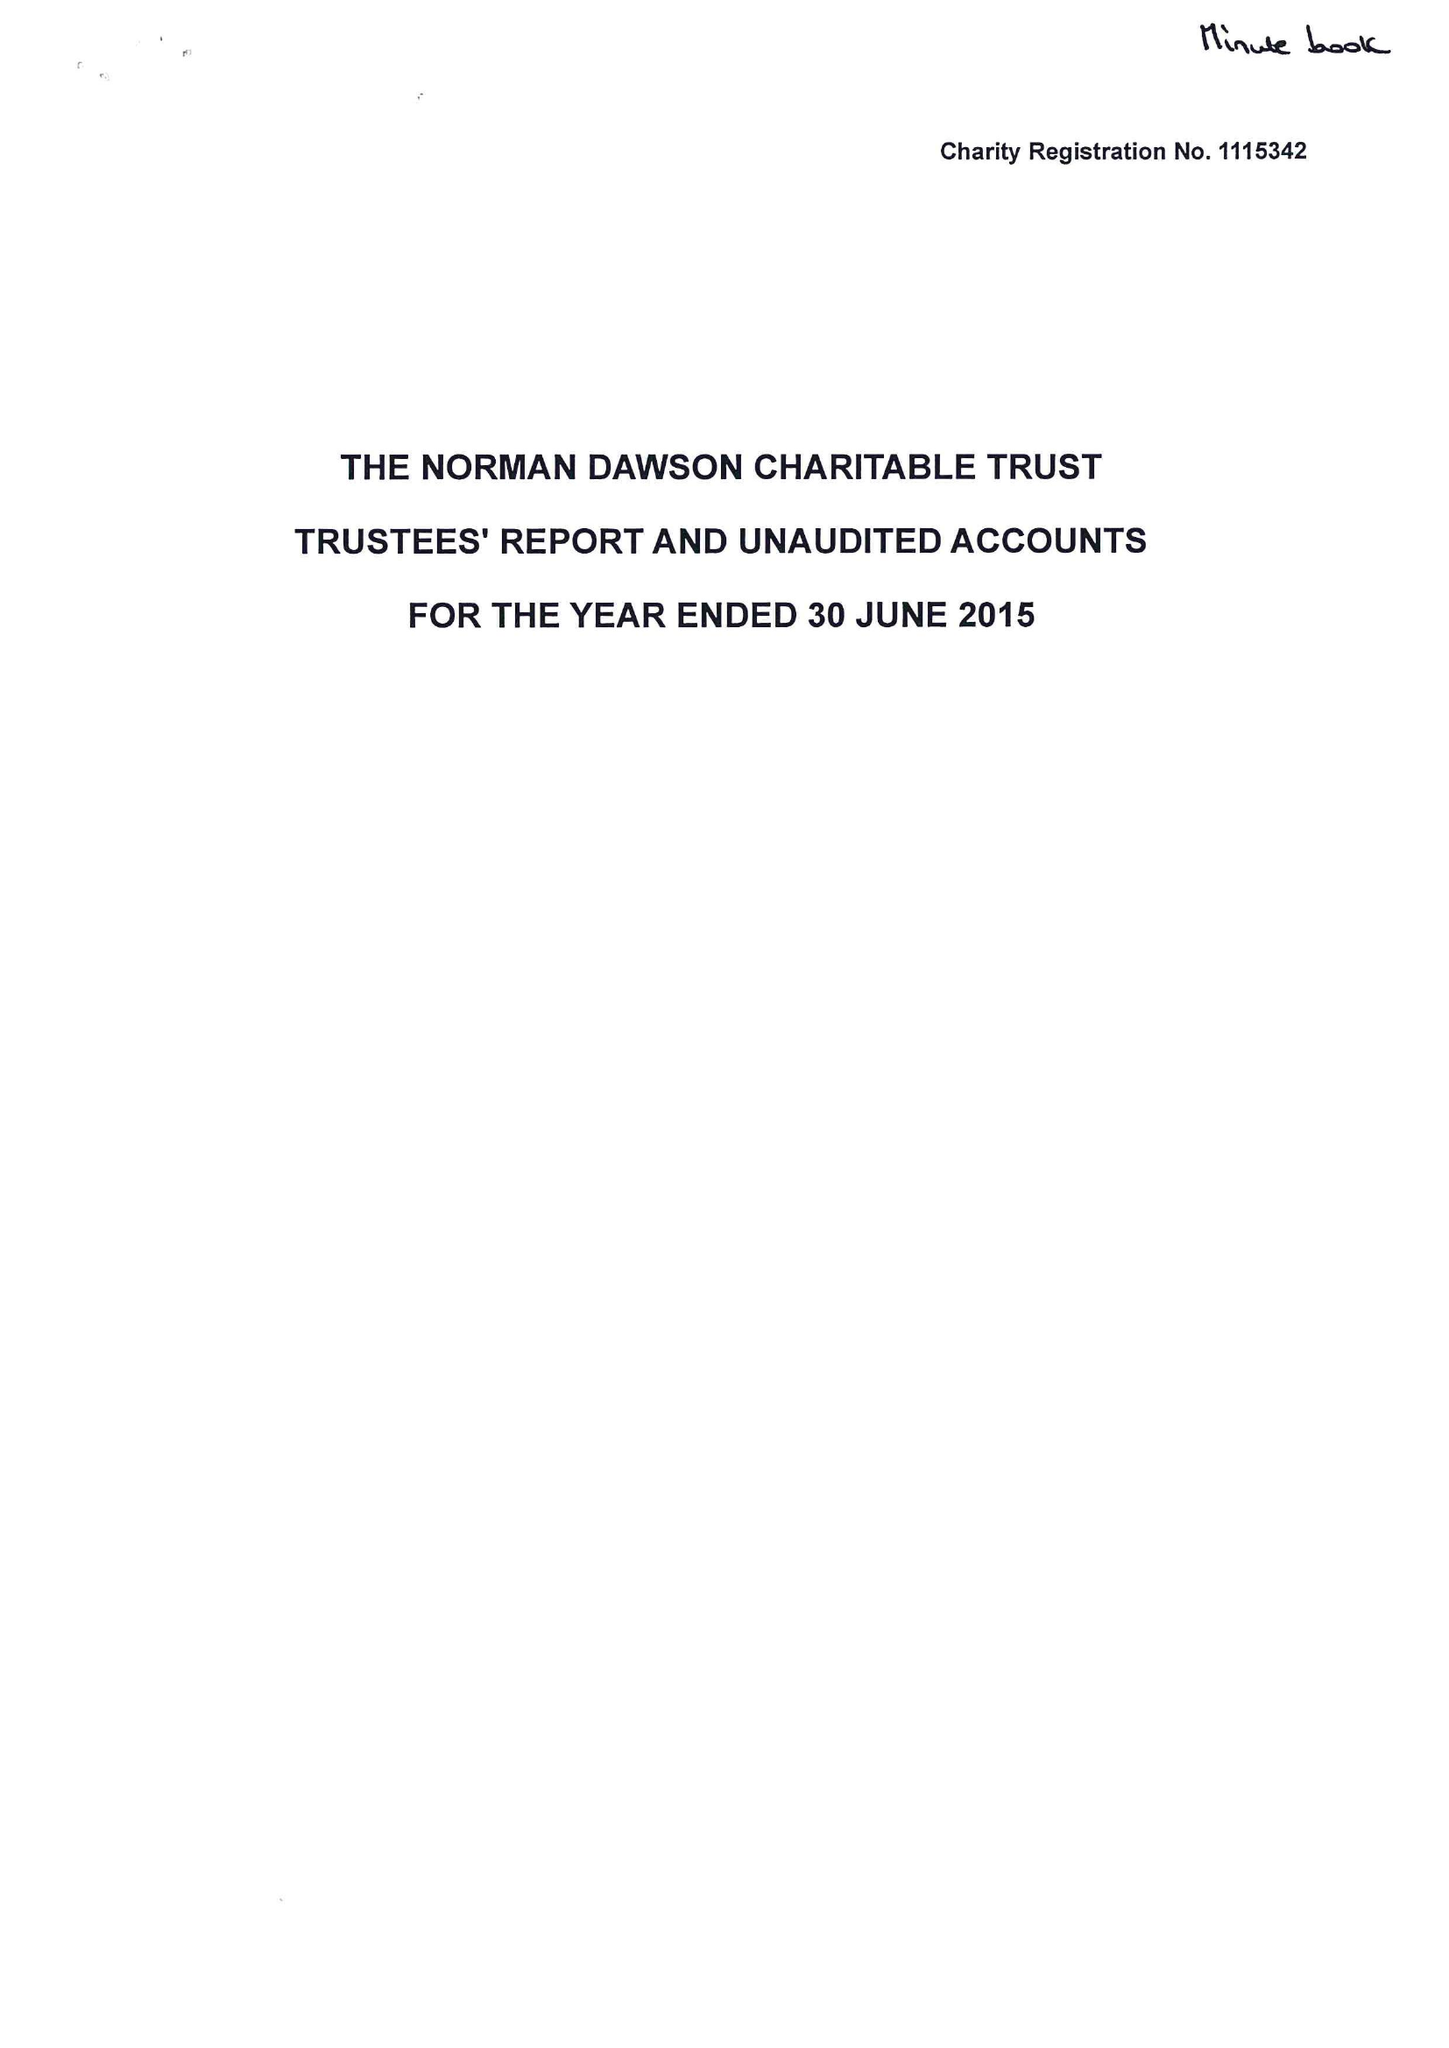What is the value for the spending_annually_in_british_pounds?
Answer the question using a single word or phrase. 49304.00 